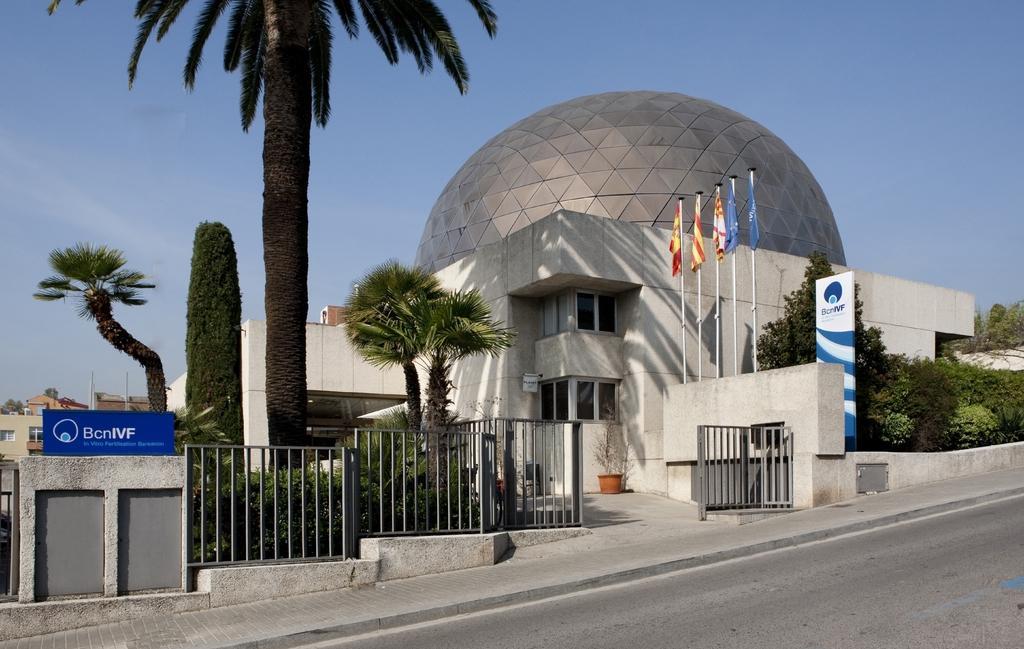In one or two sentences, can you explain what this image depicts? In the picture I can see the building and trees. I can see the glass dome structure at the top of the building. I can see the flag poles on the right side. In the foreground, I can see the metal grill fence. I can see the road at the bottom of the picture. There are clouds in the sky. 